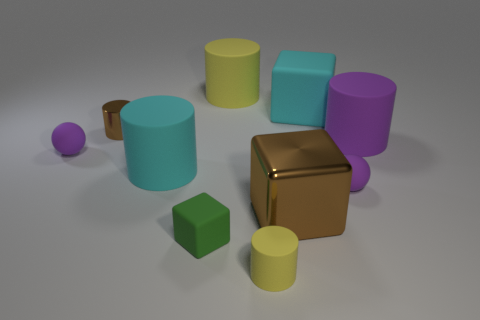What number of other objects are there of the same material as the big yellow cylinder?
Offer a very short reply. 7. There is a tiny rubber ball on the right side of the cyan object that is in front of the tiny sphere that is on the left side of the cyan rubber cylinder; what is its color?
Your response must be concise. Purple. What is the shape of the purple object that is both behind the cyan matte cylinder and to the right of the cyan matte cylinder?
Offer a very short reply. Cylinder. The small matte sphere to the right of the big cylinder that is behind the large rubber cube is what color?
Your answer should be very brief. Purple. The brown metallic thing behind the brown object that is on the right side of the large object on the left side of the green block is what shape?
Provide a succinct answer. Cylinder. There is a purple rubber thing that is both to the right of the green matte block and behind the cyan cylinder; what size is it?
Ensure brevity in your answer.  Large. What number of matte things are the same color as the shiny cylinder?
Keep it short and to the point. 0. There is a large cube that is the same color as the metallic cylinder; what is its material?
Offer a terse response. Metal. What material is the large yellow object?
Ensure brevity in your answer.  Rubber. Is the material of the tiny purple object on the right side of the green cube the same as the big cyan cube?
Provide a short and direct response. Yes. 